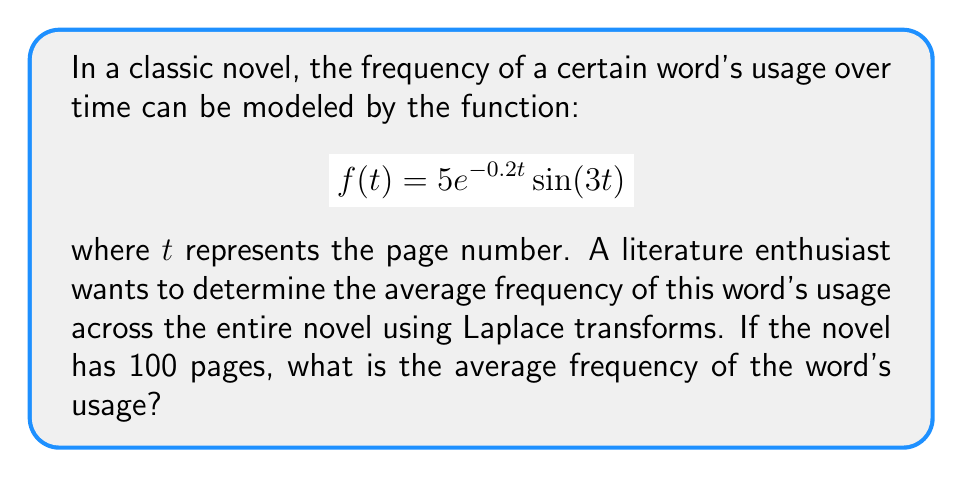Could you help me with this problem? Let's approach this step-by-step:

1) First, we need to find the Laplace transform of $f(t)$:
   $$\mathcal{L}\{f(t)\} = F(s) = \mathcal{L}\{5e^{-0.2t}\sin(3t)\}$$

2) Using the Laplace transform property for $e^{at}\sin(bt)$:
   $$F(s) = \frac{5 \cdot 3}{(s+0.2)^2 + 3^2} = \frac{15}{(s+0.2)^2 + 9}$$

3) To find the average, we need to integrate $f(t)$ over the interval $[0,100]$ and divide by 100:
   $$\text{Average} = \frac{1}{100}\int_0^{100} f(t) dt$$

4) We can use the Final Value Theorem of Laplace transforms:
   $$\lim_{t \to \infty} \int_0^t f(\tau) d\tau = \lim_{s \to 0} \frac{F(s)}{s}$$

5) Applying this:
   $$\frac{1}{100}\int_0^{100} f(t) dt \approx \frac{1}{100} \lim_{s \to 0} \frac{F(s)}{s}$$

6) Substituting $F(s)$:
   $$\frac{1}{100} \lim_{s \to 0} \frac{15}{s((s+0.2)^2 + 9)}$$

7) Evaluating the limit:
   $$\frac{1}{100} \cdot \frac{15}{0.2^2 + 9} = \frac{15}{100(9.04)} \approx 0.0166$$

Therefore, the average frequency of the word's usage across the 100 pages is approximately 0.0166.
Answer: 0.0166 